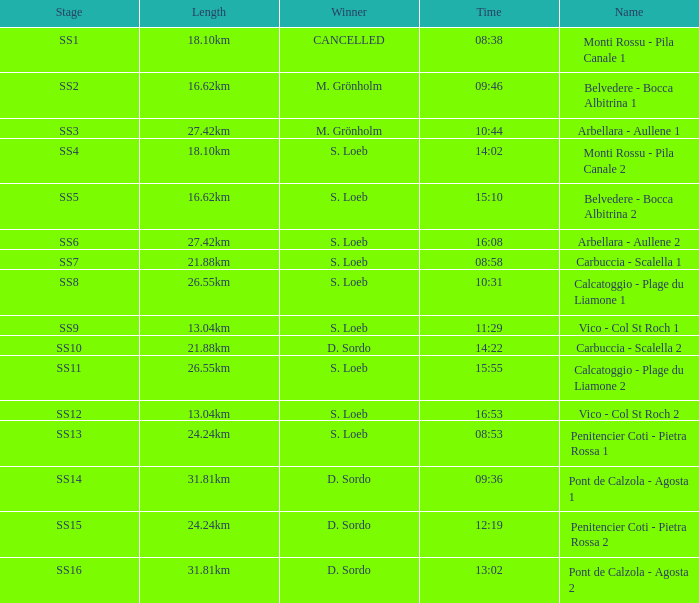What is the Name of the SS5 Stage? Belvedere - Bocca Albitrina 2. 